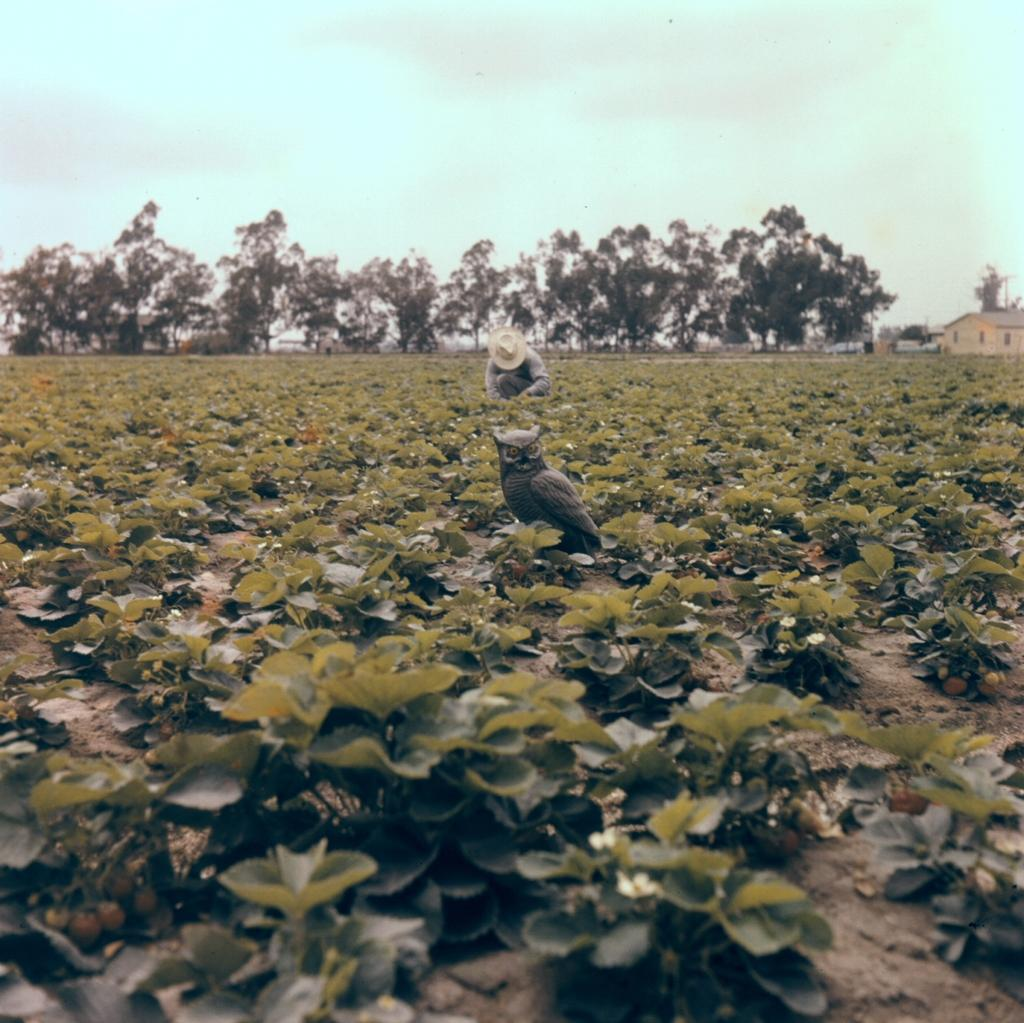What type of animal can be seen in the image? There is an owl in the image. Who else is present in the image? There is a man in the image. Where does the scene take place? The scene takes place in an agricultural farm. What can be seen in the background of the image? There are buildings, trees, and the sky visible in the background of the image. What is the condition of the sky in the image? Clouds are present in the sky. What type of books is the owl reading in the image? There are no books present in the image; it features an owl and a man in an agricultural setting. 